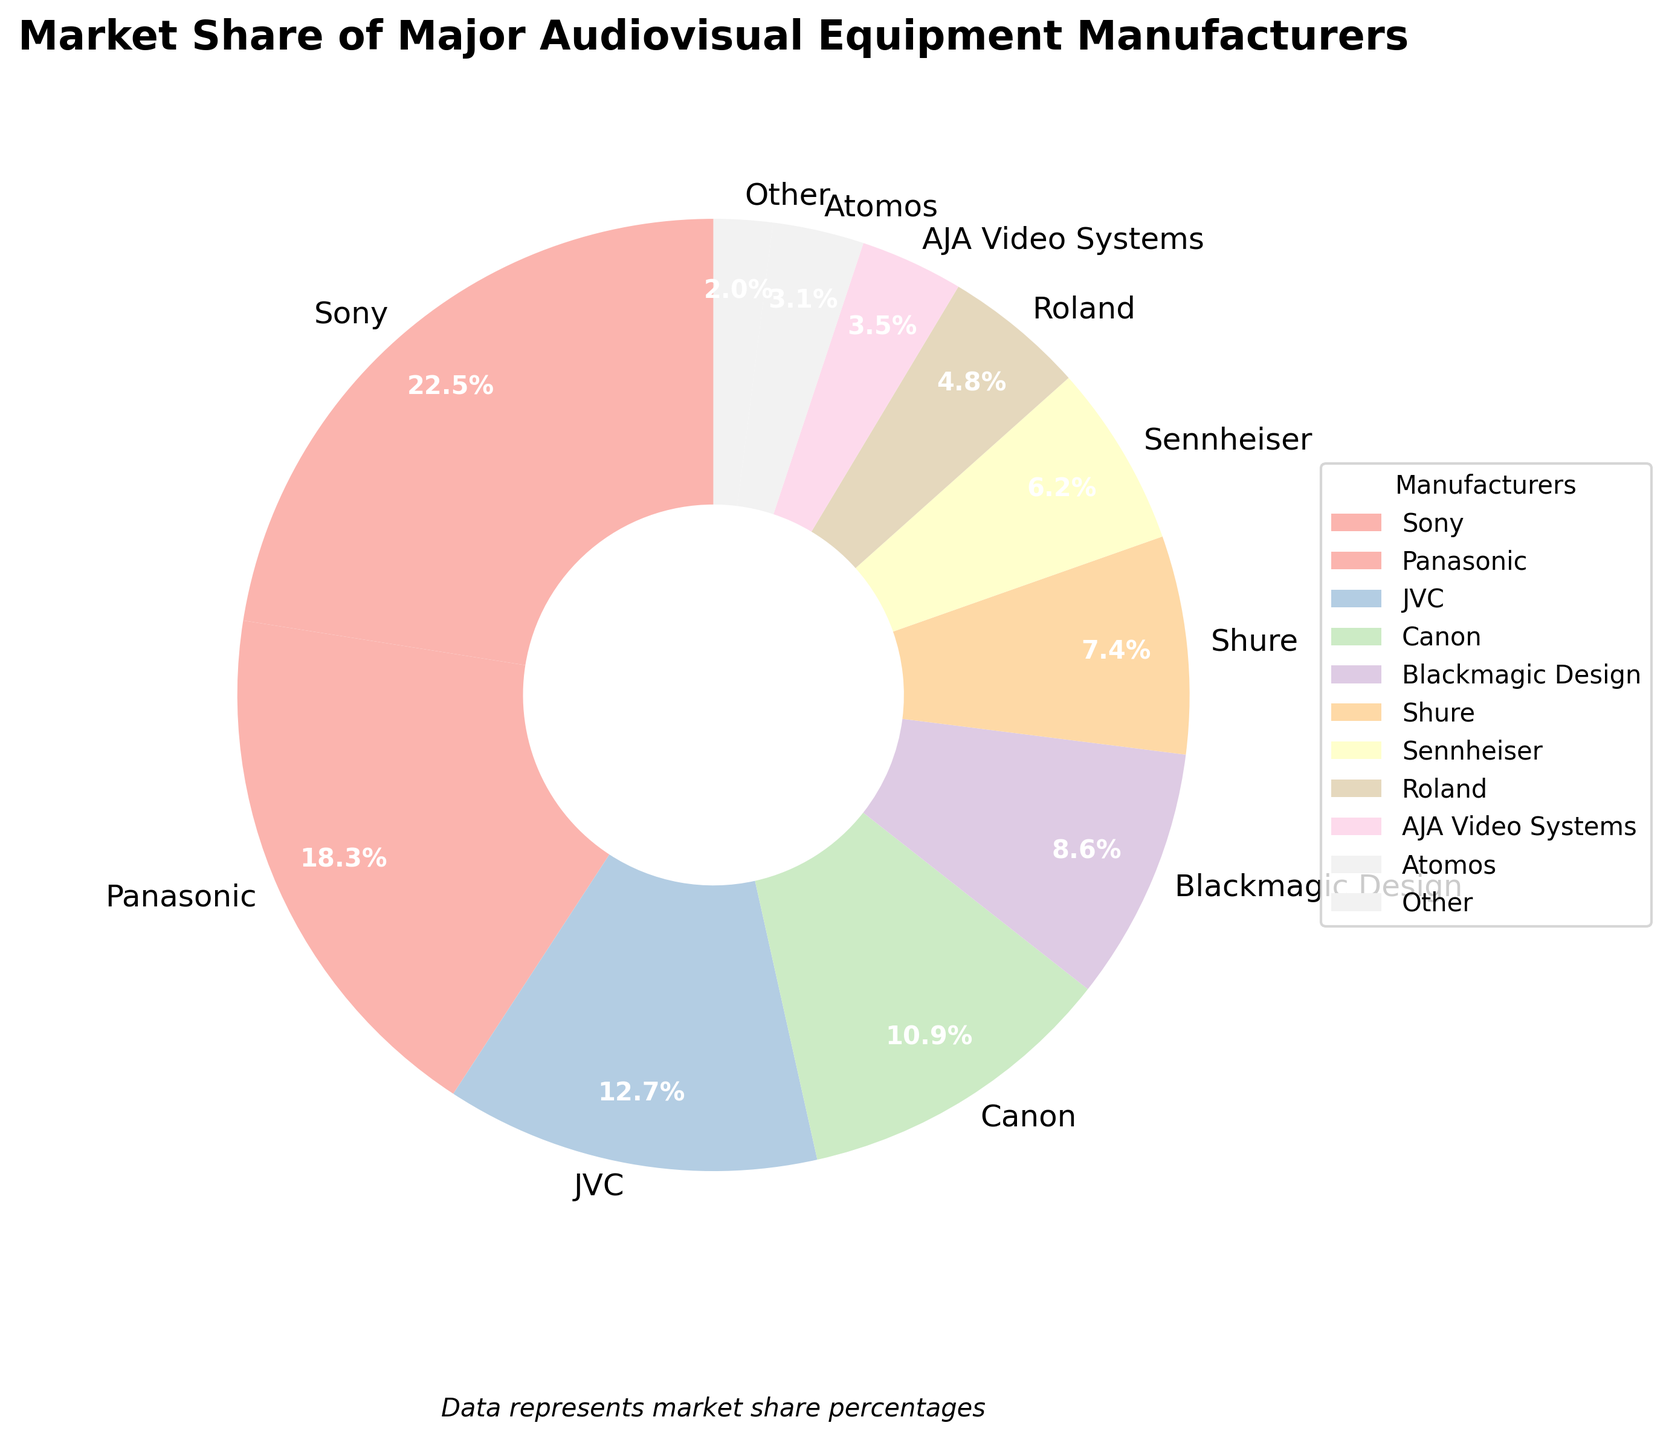Which manufacturer has the highest market share? Sony has the largest segment in the pie chart with a market share of 22.5%.
Answer: Sony What is the total market share of Sony and Panasonic combined? Sony's market share is 22.5%, and Panasonic's is 18.3%. Together, their combined market share is 22.5% + 18.3% = 40.8%.
Answer: 40.8% Is JVC's market share larger than Canon's? JVC has a market share of 12.7%, while Canon has 10.9%. Since 12.7% is greater than 10.9%, JVC's market share is larger than Canon's.
Answer: Yes How much more market share does Sony have compared to Atomos? Sony has a market share of 22.5%, and Atomos has 3.1%. The difference in market share is 22.5% - 3.1% = 19.4%.
Answer: 19.4% Which manufacturer with a market share greater than 10% has the smallest share? Among manufacturers with more than 10% market share (Sony, Panasonic, JVC, and Canon), Canon has the smallest share at 10.9%.
Answer: Canon What is the market share of manufacturers with less than 5%? Roland (4.8%), AJA Video Systems (3.5%), Atomos (3.1%), and Other (2%) fall under less than 5%. Their total is 4.8% + 3.5% + 3.1% + 2% = 13.4%.
Answer: 13.4% How does Blackmagic Design's market share compare to Shure's? Blackmagic Design's market share is 8.6%, and Shure's is 7.4%. Since 8.6% is greater than 7.4%, Blackmagic Design has a higher market share.
Answer: Blackmagic Design What's the difference between the shares of the largest and smallest manufacturers? The largest is Sony at 22.5%, and the smallest is Other at 2%. The difference is 22.5% - 2% = 20.5%.
Answer: 20.5% Which segment uses a pastel blue color in the pie chart? In the pie chart using a pastel color palette, Shure appears as the pastel blue segment.
Answer: Shure 